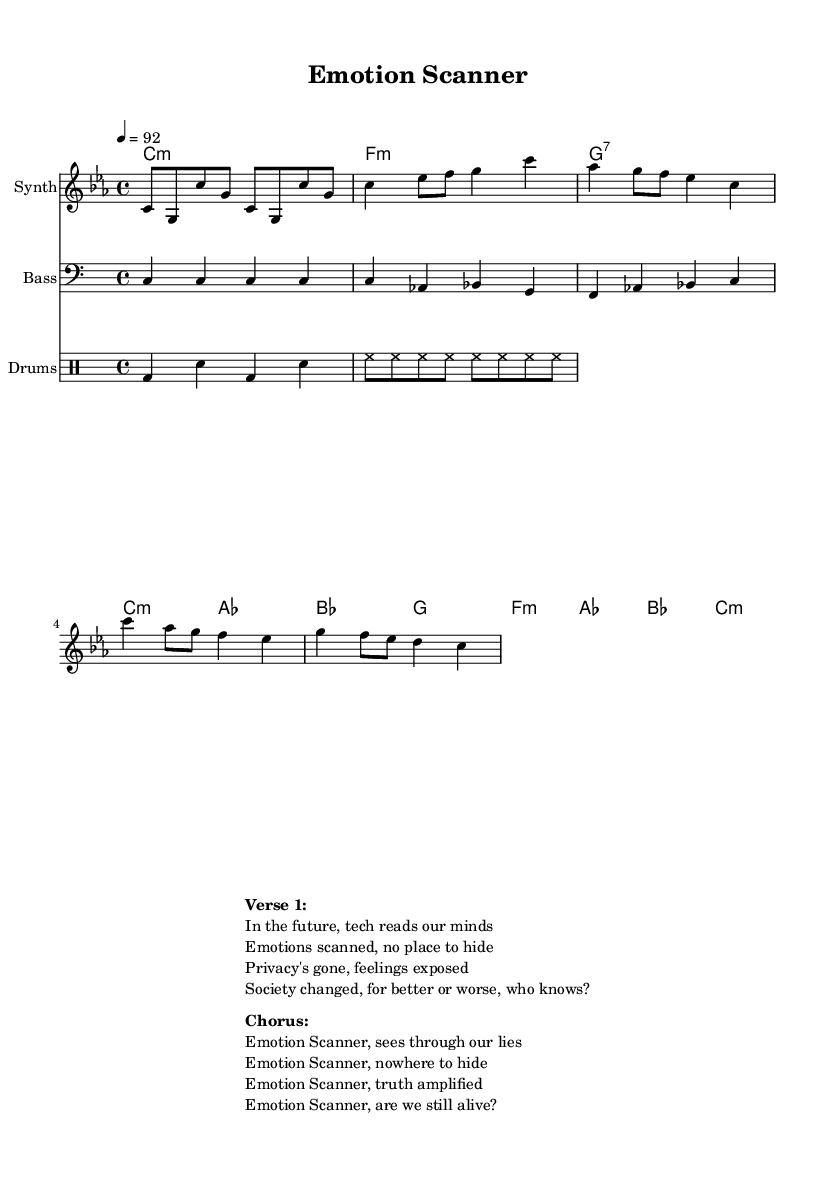What is the key signature of this music? The key signature is C minor, which has three flats (B♭, E♭, A♭). This is determined by looking at the key indicated near the start of the sheet music.
Answer: C minor What is the time signature of this music? The time signature is 4/4, which indicates four beats per measure and a quarter note gets one beat. This can be identified by looking at the numbers at the beginning of the score.
Answer: 4/4 What is the tempo marking of this music? The tempo marking is 92, indicated by "4 = 92" in the global section. This means there are 92 beats per minute.
Answer: 92 How many measures are in the verse section? The verse section consists of two measures, as seen from the music notation in the melody section. Each line in the melody represents a measure, and counting reveals there are two lines for the verse.
Answer: 2 What instrument is indicated for the melody? The instrument indicated for the melody is "Synth," specified in the score section. This gives context to the sound the composer intended for the melodic lines.
Answer: Synth What feelings are expressed in the chorus? The chorus expresses feelings of truth and exposure, as indicated by phrases like "truth amplified" and "nowhere to hide." This emotional context can be inferred from the lyrics of the chorus section.
Answer: Truth and exposure What societal concern is raised in the first verse? The societal concern raised is about the loss of privacy, as reflected in phrases like "Privacy's gone" and "feelings exposed." This concern is directly stated in the lyrics, highlighting implications of technology on personal privacy.
Answer: Loss of privacy 